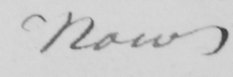What text is written in this handwritten line? Now 